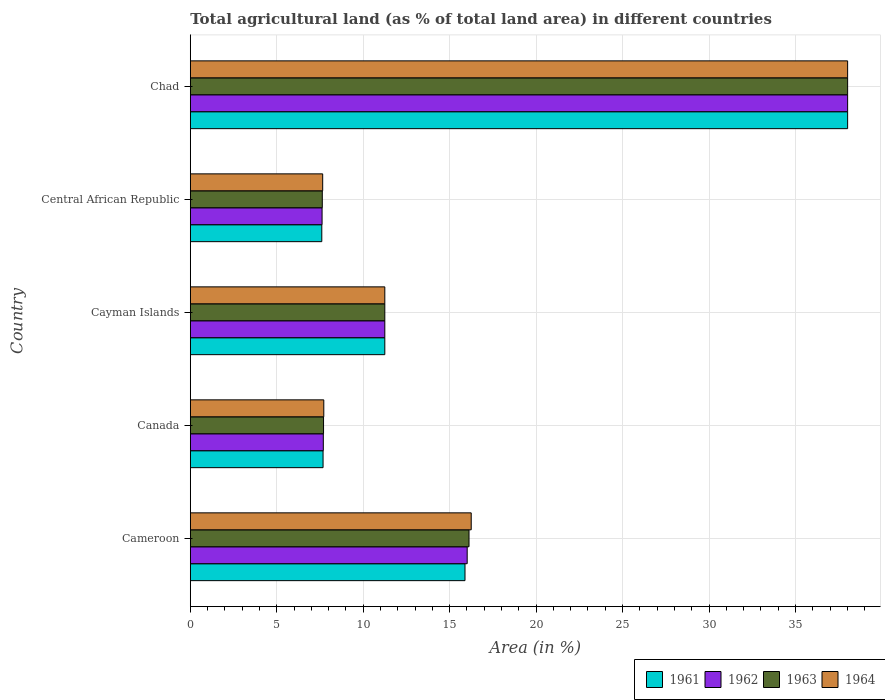How many groups of bars are there?
Provide a succinct answer. 5. How many bars are there on the 1st tick from the top?
Keep it short and to the point. 4. How many bars are there on the 5th tick from the bottom?
Keep it short and to the point. 4. What is the label of the 5th group of bars from the top?
Your answer should be compact. Cameroon. What is the percentage of agricultural land in 1964 in Cameroon?
Offer a terse response. 16.25. Across all countries, what is the maximum percentage of agricultural land in 1961?
Ensure brevity in your answer.  38.02. Across all countries, what is the minimum percentage of agricultural land in 1963?
Keep it short and to the point. 7.63. In which country was the percentage of agricultural land in 1964 maximum?
Make the answer very short. Chad. In which country was the percentage of agricultural land in 1963 minimum?
Offer a very short reply. Central African Republic. What is the total percentage of agricultural land in 1961 in the graph?
Give a very brief answer. 80.44. What is the difference between the percentage of agricultural land in 1964 in Cameroon and that in Central African Republic?
Make the answer very short. 8.59. What is the difference between the percentage of agricultural land in 1964 in Chad and the percentage of agricultural land in 1962 in Central African Republic?
Offer a very short reply. 30.39. What is the average percentage of agricultural land in 1963 per country?
Your answer should be compact. 16.15. In how many countries, is the percentage of agricultural land in 1964 greater than 31 %?
Make the answer very short. 1. What is the ratio of the percentage of agricultural land in 1963 in Cayman Islands to that in Chad?
Offer a terse response. 0.3. What is the difference between the highest and the second highest percentage of agricultural land in 1964?
Provide a short and direct response. 21.77. What is the difference between the highest and the lowest percentage of agricultural land in 1963?
Your answer should be compact. 30.38. Is the sum of the percentage of agricultural land in 1962 in Cayman Islands and Chad greater than the maximum percentage of agricultural land in 1961 across all countries?
Provide a short and direct response. Yes. Is it the case that in every country, the sum of the percentage of agricultural land in 1963 and percentage of agricultural land in 1962 is greater than the sum of percentage of agricultural land in 1961 and percentage of agricultural land in 1964?
Your response must be concise. No. What does the 1st bar from the top in Cameroon represents?
Your answer should be very brief. 1964. Are all the bars in the graph horizontal?
Offer a terse response. Yes. Does the graph contain grids?
Offer a terse response. Yes. How many legend labels are there?
Offer a terse response. 4. How are the legend labels stacked?
Give a very brief answer. Horizontal. What is the title of the graph?
Keep it short and to the point. Total agricultural land (as % of total land area) in different countries. What is the label or title of the X-axis?
Give a very brief answer. Area (in %). What is the label or title of the Y-axis?
Keep it short and to the point. Country. What is the Area (in %) in 1961 in Cameroon?
Provide a succinct answer. 15.89. What is the Area (in %) in 1962 in Cameroon?
Keep it short and to the point. 16.01. What is the Area (in %) in 1963 in Cameroon?
Provide a short and direct response. 16.12. What is the Area (in %) in 1964 in Cameroon?
Keep it short and to the point. 16.25. What is the Area (in %) of 1961 in Canada?
Give a very brief answer. 7.68. What is the Area (in %) of 1962 in Canada?
Offer a very short reply. 7.69. What is the Area (in %) of 1963 in Canada?
Keep it short and to the point. 7.71. What is the Area (in %) of 1964 in Canada?
Offer a very short reply. 7.72. What is the Area (in %) in 1961 in Cayman Islands?
Provide a short and direct response. 11.25. What is the Area (in %) of 1962 in Cayman Islands?
Provide a succinct answer. 11.25. What is the Area (in %) of 1963 in Cayman Islands?
Ensure brevity in your answer.  11.25. What is the Area (in %) of 1964 in Cayman Islands?
Your response must be concise. 11.25. What is the Area (in %) of 1961 in Central African Republic?
Make the answer very short. 7.61. What is the Area (in %) of 1962 in Central African Republic?
Give a very brief answer. 7.62. What is the Area (in %) in 1963 in Central African Republic?
Provide a short and direct response. 7.63. What is the Area (in %) in 1964 in Central African Republic?
Keep it short and to the point. 7.66. What is the Area (in %) of 1961 in Chad?
Offer a terse response. 38.02. What is the Area (in %) of 1962 in Chad?
Give a very brief answer. 38.02. What is the Area (in %) of 1963 in Chad?
Your answer should be compact. 38.02. What is the Area (in %) in 1964 in Chad?
Ensure brevity in your answer.  38.02. Across all countries, what is the maximum Area (in %) in 1961?
Provide a short and direct response. 38.02. Across all countries, what is the maximum Area (in %) in 1962?
Give a very brief answer. 38.02. Across all countries, what is the maximum Area (in %) in 1963?
Provide a short and direct response. 38.02. Across all countries, what is the maximum Area (in %) in 1964?
Offer a very short reply. 38.02. Across all countries, what is the minimum Area (in %) of 1961?
Offer a very short reply. 7.61. Across all countries, what is the minimum Area (in %) of 1962?
Your answer should be compact. 7.62. Across all countries, what is the minimum Area (in %) in 1963?
Give a very brief answer. 7.63. Across all countries, what is the minimum Area (in %) in 1964?
Keep it short and to the point. 7.66. What is the total Area (in %) in 1961 in the graph?
Provide a short and direct response. 80.44. What is the total Area (in %) of 1962 in the graph?
Ensure brevity in your answer.  80.59. What is the total Area (in %) in 1963 in the graph?
Your response must be concise. 80.73. What is the total Area (in %) in 1964 in the graph?
Provide a succinct answer. 80.89. What is the difference between the Area (in %) in 1961 in Cameroon and that in Canada?
Provide a succinct answer. 8.21. What is the difference between the Area (in %) of 1962 in Cameroon and that in Canada?
Offer a terse response. 8.32. What is the difference between the Area (in %) of 1963 in Cameroon and that in Canada?
Your response must be concise. 8.41. What is the difference between the Area (in %) of 1964 in Cameroon and that in Canada?
Provide a short and direct response. 8.53. What is the difference between the Area (in %) in 1961 in Cameroon and that in Cayman Islands?
Provide a succinct answer. 4.64. What is the difference between the Area (in %) of 1962 in Cameroon and that in Cayman Islands?
Give a very brief answer. 4.76. What is the difference between the Area (in %) of 1963 in Cameroon and that in Cayman Islands?
Ensure brevity in your answer.  4.87. What is the difference between the Area (in %) of 1964 in Cameroon and that in Cayman Islands?
Make the answer very short. 5. What is the difference between the Area (in %) in 1961 in Cameroon and that in Central African Republic?
Make the answer very short. 8.28. What is the difference between the Area (in %) of 1962 in Cameroon and that in Central African Republic?
Give a very brief answer. 8.39. What is the difference between the Area (in %) in 1963 in Cameroon and that in Central African Republic?
Offer a very short reply. 8.49. What is the difference between the Area (in %) in 1964 in Cameroon and that in Central African Republic?
Give a very brief answer. 8.59. What is the difference between the Area (in %) in 1961 in Cameroon and that in Chad?
Your answer should be compact. -22.13. What is the difference between the Area (in %) in 1962 in Cameroon and that in Chad?
Provide a short and direct response. -22. What is the difference between the Area (in %) of 1963 in Cameroon and that in Chad?
Your response must be concise. -21.9. What is the difference between the Area (in %) in 1964 in Cameroon and that in Chad?
Give a very brief answer. -21.77. What is the difference between the Area (in %) in 1961 in Canada and that in Cayman Islands?
Your answer should be very brief. -3.57. What is the difference between the Area (in %) of 1962 in Canada and that in Cayman Islands?
Your answer should be very brief. -3.56. What is the difference between the Area (in %) in 1963 in Canada and that in Cayman Islands?
Your response must be concise. -3.54. What is the difference between the Area (in %) in 1964 in Canada and that in Cayman Islands?
Keep it short and to the point. -3.53. What is the difference between the Area (in %) in 1961 in Canada and that in Central African Republic?
Provide a short and direct response. 0.07. What is the difference between the Area (in %) of 1962 in Canada and that in Central African Republic?
Give a very brief answer. 0.07. What is the difference between the Area (in %) of 1963 in Canada and that in Central African Republic?
Make the answer very short. 0.07. What is the difference between the Area (in %) in 1964 in Canada and that in Central African Republic?
Give a very brief answer. 0.06. What is the difference between the Area (in %) in 1961 in Canada and that in Chad?
Keep it short and to the point. -30.34. What is the difference between the Area (in %) in 1962 in Canada and that in Chad?
Provide a short and direct response. -30.32. What is the difference between the Area (in %) of 1963 in Canada and that in Chad?
Your response must be concise. -30.31. What is the difference between the Area (in %) of 1964 in Canada and that in Chad?
Offer a terse response. -30.3. What is the difference between the Area (in %) in 1961 in Cayman Islands and that in Central African Republic?
Give a very brief answer. 3.64. What is the difference between the Area (in %) of 1962 in Cayman Islands and that in Central African Republic?
Your answer should be compact. 3.63. What is the difference between the Area (in %) of 1963 in Cayman Islands and that in Central African Republic?
Provide a succinct answer. 3.62. What is the difference between the Area (in %) in 1964 in Cayman Islands and that in Central African Republic?
Give a very brief answer. 3.59. What is the difference between the Area (in %) in 1961 in Cayman Islands and that in Chad?
Provide a succinct answer. -26.77. What is the difference between the Area (in %) in 1962 in Cayman Islands and that in Chad?
Ensure brevity in your answer.  -26.77. What is the difference between the Area (in %) of 1963 in Cayman Islands and that in Chad?
Your answer should be very brief. -26.77. What is the difference between the Area (in %) in 1964 in Cayman Islands and that in Chad?
Give a very brief answer. -26.77. What is the difference between the Area (in %) of 1961 in Central African Republic and that in Chad?
Your response must be concise. -30.41. What is the difference between the Area (in %) of 1962 in Central African Republic and that in Chad?
Make the answer very short. -30.39. What is the difference between the Area (in %) of 1963 in Central African Republic and that in Chad?
Offer a very short reply. -30.38. What is the difference between the Area (in %) of 1964 in Central African Republic and that in Chad?
Your response must be concise. -30.36. What is the difference between the Area (in %) of 1961 in Cameroon and the Area (in %) of 1962 in Canada?
Provide a short and direct response. 8.19. What is the difference between the Area (in %) of 1961 in Cameroon and the Area (in %) of 1963 in Canada?
Your answer should be very brief. 8.18. What is the difference between the Area (in %) of 1961 in Cameroon and the Area (in %) of 1964 in Canada?
Offer a very short reply. 8.17. What is the difference between the Area (in %) of 1962 in Cameroon and the Area (in %) of 1963 in Canada?
Offer a terse response. 8.31. What is the difference between the Area (in %) of 1962 in Cameroon and the Area (in %) of 1964 in Canada?
Your response must be concise. 8.29. What is the difference between the Area (in %) in 1963 in Cameroon and the Area (in %) in 1964 in Canada?
Your answer should be compact. 8.4. What is the difference between the Area (in %) of 1961 in Cameroon and the Area (in %) of 1962 in Cayman Islands?
Offer a terse response. 4.64. What is the difference between the Area (in %) in 1961 in Cameroon and the Area (in %) in 1963 in Cayman Islands?
Your answer should be very brief. 4.64. What is the difference between the Area (in %) of 1961 in Cameroon and the Area (in %) of 1964 in Cayman Islands?
Offer a very short reply. 4.64. What is the difference between the Area (in %) of 1962 in Cameroon and the Area (in %) of 1963 in Cayman Islands?
Your response must be concise. 4.76. What is the difference between the Area (in %) of 1962 in Cameroon and the Area (in %) of 1964 in Cayman Islands?
Give a very brief answer. 4.76. What is the difference between the Area (in %) in 1963 in Cameroon and the Area (in %) in 1964 in Cayman Islands?
Keep it short and to the point. 4.87. What is the difference between the Area (in %) of 1961 in Cameroon and the Area (in %) of 1962 in Central African Republic?
Your response must be concise. 8.27. What is the difference between the Area (in %) of 1961 in Cameroon and the Area (in %) of 1963 in Central African Republic?
Give a very brief answer. 8.25. What is the difference between the Area (in %) of 1961 in Cameroon and the Area (in %) of 1964 in Central African Republic?
Make the answer very short. 8.23. What is the difference between the Area (in %) in 1962 in Cameroon and the Area (in %) in 1963 in Central African Republic?
Offer a terse response. 8.38. What is the difference between the Area (in %) in 1962 in Cameroon and the Area (in %) in 1964 in Central African Republic?
Your answer should be compact. 8.36. What is the difference between the Area (in %) of 1963 in Cameroon and the Area (in %) of 1964 in Central African Republic?
Your response must be concise. 8.46. What is the difference between the Area (in %) of 1961 in Cameroon and the Area (in %) of 1962 in Chad?
Your response must be concise. -22.13. What is the difference between the Area (in %) in 1961 in Cameroon and the Area (in %) in 1963 in Chad?
Give a very brief answer. -22.13. What is the difference between the Area (in %) in 1961 in Cameroon and the Area (in %) in 1964 in Chad?
Offer a very short reply. -22.13. What is the difference between the Area (in %) of 1962 in Cameroon and the Area (in %) of 1963 in Chad?
Provide a short and direct response. -22. What is the difference between the Area (in %) of 1962 in Cameroon and the Area (in %) of 1964 in Chad?
Make the answer very short. -22. What is the difference between the Area (in %) in 1963 in Cameroon and the Area (in %) in 1964 in Chad?
Keep it short and to the point. -21.9. What is the difference between the Area (in %) in 1961 in Canada and the Area (in %) in 1962 in Cayman Islands?
Ensure brevity in your answer.  -3.57. What is the difference between the Area (in %) in 1961 in Canada and the Area (in %) in 1963 in Cayman Islands?
Make the answer very short. -3.57. What is the difference between the Area (in %) in 1961 in Canada and the Area (in %) in 1964 in Cayman Islands?
Provide a short and direct response. -3.57. What is the difference between the Area (in %) in 1962 in Canada and the Area (in %) in 1963 in Cayman Islands?
Make the answer very short. -3.56. What is the difference between the Area (in %) of 1962 in Canada and the Area (in %) of 1964 in Cayman Islands?
Make the answer very short. -3.56. What is the difference between the Area (in %) in 1963 in Canada and the Area (in %) in 1964 in Cayman Islands?
Your answer should be compact. -3.54. What is the difference between the Area (in %) in 1961 in Canada and the Area (in %) in 1962 in Central African Republic?
Keep it short and to the point. 0.06. What is the difference between the Area (in %) in 1961 in Canada and the Area (in %) in 1963 in Central African Republic?
Your response must be concise. 0.04. What is the difference between the Area (in %) in 1961 in Canada and the Area (in %) in 1964 in Central African Republic?
Your answer should be very brief. 0.02. What is the difference between the Area (in %) in 1962 in Canada and the Area (in %) in 1963 in Central African Republic?
Your answer should be compact. 0.06. What is the difference between the Area (in %) of 1962 in Canada and the Area (in %) of 1964 in Central African Republic?
Keep it short and to the point. 0.04. What is the difference between the Area (in %) of 1961 in Canada and the Area (in %) of 1962 in Chad?
Make the answer very short. -30.34. What is the difference between the Area (in %) of 1961 in Canada and the Area (in %) of 1963 in Chad?
Keep it short and to the point. -30.34. What is the difference between the Area (in %) of 1961 in Canada and the Area (in %) of 1964 in Chad?
Keep it short and to the point. -30.34. What is the difference between the Area (in %) in 1962 in Canada and the Area (in %) in 1963 in Chad?
Make the answer very short. -30.32. What is the difference between the Area (in %) of 1962 in Canada and the Area (in %) of 1964 in Chad?
Give a very brief answer. -30.32. What is the difference between the Area (in %) of 1963 in Canada and the Area (in %) of 1964 in Chad?
Offer a very short reply. -30.31. What is the difference between the Area (in %) of 1961 in Cayman Islands and the Area (in %) of 1962 in Central African Republic?
Your answer should be very brief. 3.63. What is the difference between the Area (in %) in 1961 in Cayman Islands and the Area (in %) in 1963 in Central African Republic?
Give a very brief answer. 3.62. What is the difference between the Area (in %) in 1961 in Cayman Islands and the Area (in %) in 1964 in Central African Republic?
Ensure brevity in your answer.  3.59. What is the difference between the Area (in %) in 1962 in Cayman Islands and the Area (in %) in 1963 in Central African Republic?
Your answer should be very brief. 3.62. What is the difference between the Area (in %) of 1962 in Cayman Islands and the Area (in %) of 1964 in Central African Republic?
Offer a terse response. 3.59. What is the difference between the Area (in %) in 1963 in Cayman Islands and the Area (in %) in 1964 in Central African Republic?
Provide a short and direct response. 3.59. What is the difference between the Area (in %) of 1961 in Cayman Islands and the Area (in %) of 1962 in Chad?
Your answer should be compact. -26.77. What is the difference between the Area (in %) of 1961 in Cayman Islands and the Area (in %) of 1963 in Chad?
Ensure brevity in your answer.  -26.77. What is the difference between the Area (in %) in 1961 in Cayman Islands and the Area (in %) in 1964 in Chad?
Provide a short and direct response. -26.77. What is the difference between the Area (in %) of 1962 in Cayman Islands and the Area (in %) of 1963 in Chad?
Provide a short and direct response. -26.77. What is the difference between the Area (in %) of 1962 in Cayman Islands and the Area (in %) of 1964 in Chad?
Offer a very short reply. -26.77. What is the difference between the Area (in %) in 1963 in Cayman Islands and the Area (in %) in 1964 in Chad?
Offer a very short reply. -26.77. What is the difference between the Area (in %) of 1961 in Central African Republic and the Area (in %) of 1962 in Chad?
Make the answer very short. -30.41. What is the difference between the Area (in %) of 1961 in Central African Republic and the Area (in %) of 1963 in Chad?
Provide a short and direct response. -30.41. What is the difference between the Area (in %) in 1961 in Central African Republic and the Area (in %) in 1964 in Chad?
Your answer should be very brief. -30.41. What is the difference between the Area (in %) of 1962 in Central African Republic and the Area (in %) of 1963 in Chad?
Offer a terse response. -30.39. What is the difference between the Area (in %) in 1962 in Central African Republic and the Area (in %) in 1964 in Chad?
Your answer should be very brief. -30.39. What is the difference between the Area (in %) of 1963 in Central African Republic and the Area (in %) of 1964 in Chad?
Provide a succinct answer. -30.38. What is the average Area (in %) in 1961 per country?
Make the answer very short. 16.09. What is the average Area (in %) of 1962 per country?
Give a very brief answer. 16.12. What is the average Area (in %) of 1963 per country?
Ensure brevity in your answer.  16.15. What is the average Area (in %) in 1964 per country?
Your answer should be very brief. 16.18. What is the difference between the Area (in %) in 1961 and Area (in %) in 1962 in Cameroon?
Your answer should be very brief. -0.13. What is the difference between the Area (in %) of 1961 and Area (in %) of 1963 in Cameroon?
Ensure brevity in your answer.  -0.23. What is the difference between the Area (in %) of 1961 and Area (in %) of 1964 in Cameroon?
Give a very brief answer. -0.36. What is the difference between the Area (in %) of 1962 and Area (in %) of 1963 in Cameroon?
Offer a very short reply. -0.11. What is the difference between the Area (in %) in 1962 and Area (in %) in 1964 in Cameroon?
Keep it short and to the point. -0.23. What is the difference between the Area (in %) in 1963 and Area (in %) in 1964 in Cameroon?
Offer a very short reply. -0.13. What is the difference between the Area (in %) in 1961 and Area (in %) in 1962 in Canada?
Your answer should be compact. -0.01. What is the difference between the Area (in %) of 1961 and Area (in %) of 1963 in Canada?
Offer a very short reply. -0.03. What is the difference between the Area (in %) of 1961 and Area (in %) of 1964 in Canada?
Offer a terse response. -0.04. What is the difference between the Area (in %) of 1962 and Area (in %) of 1963 in Canada?
Make the answer very short. -0.01. What is the difference between the Area (in %) of 1962 and Area (in %) of 1964 in Canada?
Keep it short and to the point. -0.03. What is the difference between the Area (in %) in 1963 and Area (in %) in 1964 in Canada?
Make the answer very short. -0.01. What is the difference between the Area (in %) in 1961 and Area (in %) in 1962 in Cayman Islands?
Ensure brevity in your answer.  0. What is the difference between the Area (in %) in 1961 and Area (in %) in 1963 in Cayman Islands?
Give a very brief answer. 0. What is the difference between the Area (in %) in 1962 and Area (in %) in 1964 in Cayman Islands?
Offer a terse response. 0. What is the difference between the Area (in %) of 1963 and Area (in %) of 1964 in Cayman Islands?
Your response must be concise. 0. What is the difference between the Area (in %) in 1961 and Area (in %) in 1962 in Central African Republic?
Offer a terse response. -0.02. What is the difference between the Area (in %) in 1961 and Area (in %) in 1963 in Central African Republic?
Provide a short and direct response. -0.03. What is the difference between the Area (in %) of 1961 and Area (in %) of 1964 in Central African Republic?
Ensure brevity in your answer.  -0.05. What is the difference between the Area (in %) in 1962 and Area (in %) in 1963 in Central African Republic?
Give a very brief answer. -0.01. What is the difference between the Area (in %) in 1962 and Area (in %) in 1964 in Central African Republic?
Keep it short and to the point. -0.04. What is the difference between the Area (in %) of 1963 and Area (in %) of 1964 in Central African Republic?
Offer a very short reply. -0.02. What is the difference between the Area (in %) of 1961 and Area (in %) of 1962 in Chad?
Provide a succinct answer. 0. What is the difference between the Area (in %) in 1961 and Area (in %) in 1963 in Chad?
Offer a terse response. 0. What is the difference between the Area (in %) in 1962 and Area (in %) in 1963 in Chad?
Provide a short and direct response. 0. What is the ratio of the Area (in %) of 1961 in Cameroon to that in Canada?
Ensure brevity in your answer.  2.07. What is the ratio of the Area (in %) in 1962 in Cameroon to that in Canada?
Provide a succinct answer. 2.08. What is the ratio of the Area (in %) of 1963 in Cameroon to that in Canada?
Keep it short and to the point. 2.09. What is the ratio of the Area (in %) in 1964 in Cameroon to that in Canada?
Your answer should be very brief. 2.1. What is the ratio of the Area (in %) of 1961 in Cameroon to that in Cayman Islands?
Keep it short and to the point. 1.41. What is the ratio of the Area (in %) in 1962 in Cameroon to that in Cayman Islands?
Ensure brevity in your answer.  1.42. What is the ratio of the Area (in %) of 1963 in Cameroon to that in Cayman Islands?
Make the answer very short. 1.43. What is the ratio of the Area (in %) in 1964 in Cameroon to that in Cayman Islands?
Your answer should be compact. 1.44. What is the ratio of the Area (in %) of 1961 in Cameroon to that in Central African Republic?
Your answer should be compact. 2.09. What is the ratio of the Area (in %) in 1962 in Cameroon to that in Central African Republic?
Give a very brief answer. 2.1. What is the ratio of the Area (in %) in 1963 in Cameroon to that in Central African Republic?
Your answer should be very brief. 2.11. What is the ratio of the Area (in %) in 1964 in Cameroon to that in Central African Republic?
Your response must be concise. 2.12. What is the ratio of the Area (in %) in 1961 in Cameroon to that in Chad?
Ensure brevity in your answer.  0.42. What is the ratio of the Area (in %) of 1962 in Cameroon to that in Chad?
Provide a succinct answer. 0.42. What is the ratio of the Area (in %) in 1963 in Cameroon to that in Chad?
Provide a short and direct response. 0.42. What is the ratio of the Area (in %) of 1964 in Cameroon to that in Chad?
Your response must be concise. 0.43. What is the ratio of the Area (in %) in 1961 in Canada to that in Cayman Islands?
Your response must be concise. 0.68. What is the ratio of the Area (in %) in 1962 in Canada to that in Cayman Islands?
Keep it short and to the point. 0.68. What is the ratio of the Area (in %) in 1963 in Canada to that in Cayman Islands?
Offer a terse response. 0.69. What is the ratio of the Area (in %) of 1964 in Canada to that in Cayman Islands?
Your answer should be compact. 0.69. What is the ratio of the Area (in %) in 1961 in Canada to that in Central African Republic?
Keep it short and to the point. 1.01. What is the ratio of the Area (in %) of 1962 in Canada to that in Central African Republic?
Your answer should be compact. 1.01. What is the ratio of the Area (in %) in 1963 in Canada to that in Central African Republic?
Offer a very short reply. 1.01. What is the ratio of the Area (in %) of 1964 in Canada to that in Central African Republic?
Offer a terse response. 1.01. What is the ratio of the Area (in %) in 1961 in Canada to that in Chad?
Provide a succinct answer. 0.2. What is the ratio of the Area (in %) in 1962 in Canada to that in Chad?
Ensure brevity in your answer.  0.2. What is the ratio of the Area (in %) in 1963 in Canada to that in Chad?
Provide a succinct answer. 0.2. What is the ratio of the Area (in %) in 1964 in Canada to that in Chad?
Give a very brief answer. 0.2. What is the ratio of the Area (in %) in 1961 in Cayman Islands to that in Central African Republic?
Provide a short and direct response. 1.48. What is the ratio of the Area (in %) of 1962 in Cayman Islands to that in Central African Republic?
Ensure brevity in your answer.  1.48. What is the ratio of the Area (in %) in 1963 in Cayman Islands to that in Central African Republic?
Offer a very short reply. 1.47. What is the ratio of the Area (in %) in 1964 in Cayman Islands to that in Central African Republic?
Your answer should be very brief. 1.47. What is the ratio of the Area (in %) in 1961 in Cayman Islands to that in Chad?
Give a very brief answer. 0.3. What is the ratio of the Area (in %) of 1962 in Cayman Islands to that in Chad?
Your answer should be compact. 0.3. What is the ratio of the Area (in %) of 1963 in Cayman Islands to that in Chad?
Make the answer very short. 0.3. What is the ratio of the Area (in %) in 1964 in Cayman Islands to that in Chad?
Your answer should be compact. 0.3. What is the ratio of the Area (in %) in 1961 in Central African Republic to that in Chad?
Your answer should be very brief. 0.2. What is the ratio of the Area (in %) of 1962 in Central African Republic to that in Chad?
Ensure brevity in your answer.  0.2. What is the ratio of the Area (in %) of 1963 in Central African Republic to that in Chad?
Your answer should be very brief. 0.2. What is the ratio of the Area (in %) in 1964 in Central African Republic to that in Chad?
Offer a terse response. 0.2. What is the difference between the highest and the second highest Area (in %) in 1961?
Provide a short and direct response. 22.13. What is the difference between the highest and the second highest Area (in %) in 1962?
Make the answer very short. 22. What is the difference between the highest and the second highest Area (in %) of 1963?
Your answer should be very brief. 21.9. What is the difference between the highest and the second highest Area (in %) in 1964?
Make the answer very short. 21.77. What is the difference between the highest and the lowest Area (in %) of 1961?
Make the answer very short. 30.41. What is the difference between the highest and the lowest Area (in %) of 1962?
Your answer should be very brief. 30.39. What is the difference between the highest and the lowest Area (in %) in 1963?
Your response must be concise. 30.38. What is the difference between the highest and the lowest Area (in %) in 1964?
Ensure brevity in your answer.  30.36. 